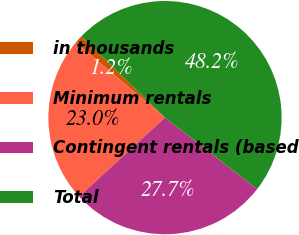<chart> <loc_0><loc_0><loc_500><loc_500><pie_chart><fcel>in thousands<fcel>Minimum rentals<fcel>Contingent rentals (based<fcel>Total<nl><fcel>1.15%<fcel>22.97%<fcel>27.67%<fcel>48.2%<nl></chart> 